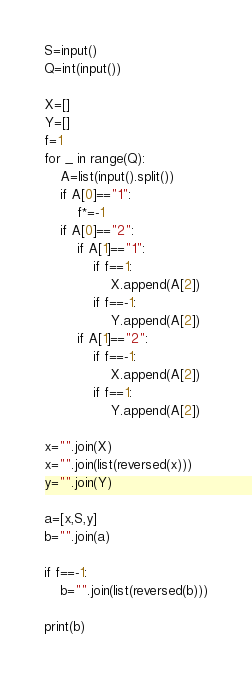<code> <loc_0><loc_0><loc_500><loc_500><_Python_>S=input()
Q=int(input())

X=[]
Y=[]
f=1
for _ in range(Q):
    A=list(input().split())
    if A[0]=="1":
        f*=-1
    if A[0]=="2":
        if A[1]=="1":
            if f==1:
                X.append(A[2])
            if f==-1:
                Y.append(A[2])
        if A[1]=="2":
            if f==-1:
                X.append(A[2])
            if f==1:
                Y.append(A[2])

x="".join(X)
x="".join(list(reversed(x)))
y="".join(Y)

a=[x,S,y]
b="".join(a)

if f==-1:
    b="".join(list(reversed(b)))

print(b)
</code> 